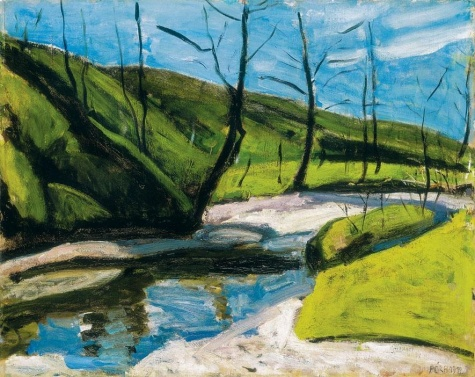What might be the significance of the season depicted in this artwork? The season depicted is likely early spring, a time of renewal and awakening in nature. This season has often been symbolic of new beginnings and hope. By choosing this time of year, the artist might be subtly suggesting themes of rejuvenation and the cyclical nature of life. This could resonate on a personal level with the viewer, or perhaps reflect a period in the artist's life of transformation and fresh starts. 